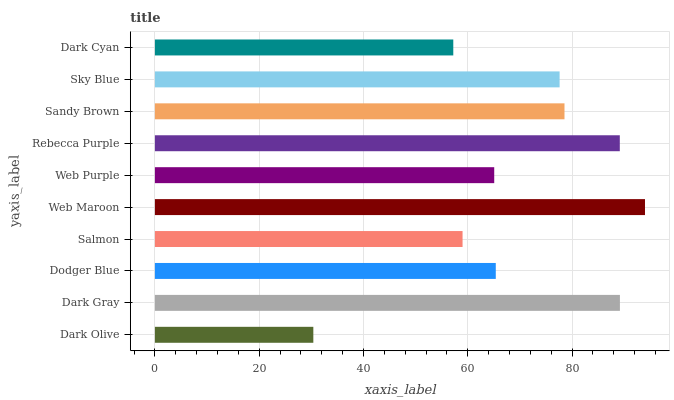Is Dark Olive the minimum?
Answer yes or no. Yes. Is Web Maroon the maximum?
Answer yes or no. Yes. Is Dark Gray the minimum?
Answer yes or no. No. Is Dark Gray the maximum?
Answer yes or no. No. Is Dark Gray greater than Dark Olive?
Answer yes or no. Yes. Is Dark Olive less than Dark Gray?
Answer yes or no. Yes. Is Dark Olive greater than Dark Gray?
Answer yes or no. No. Is Dark Gray less than Dark Olive?
Answer yes or no. No. Is Sky Blue the high median?
Answer yes or no. Yes. Is Dodger Blue the low median?
Answer yes or no. Yes. Is Dark Olive the high median?
Answer yes or no. No. Is Sky Blue the low median?
Answer yes or no. No. 